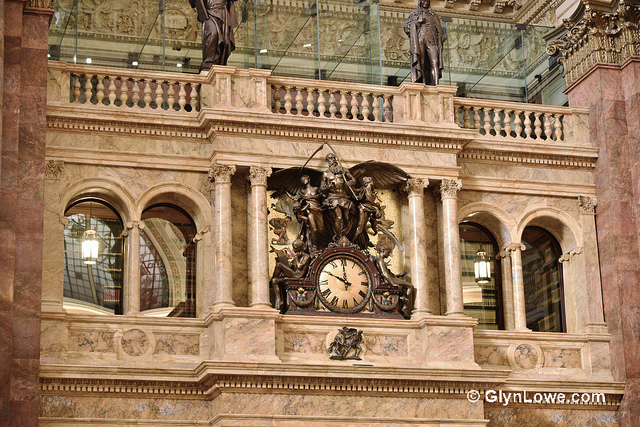Please transcribe the text information in this image. &#169; GlynLowe.com A 